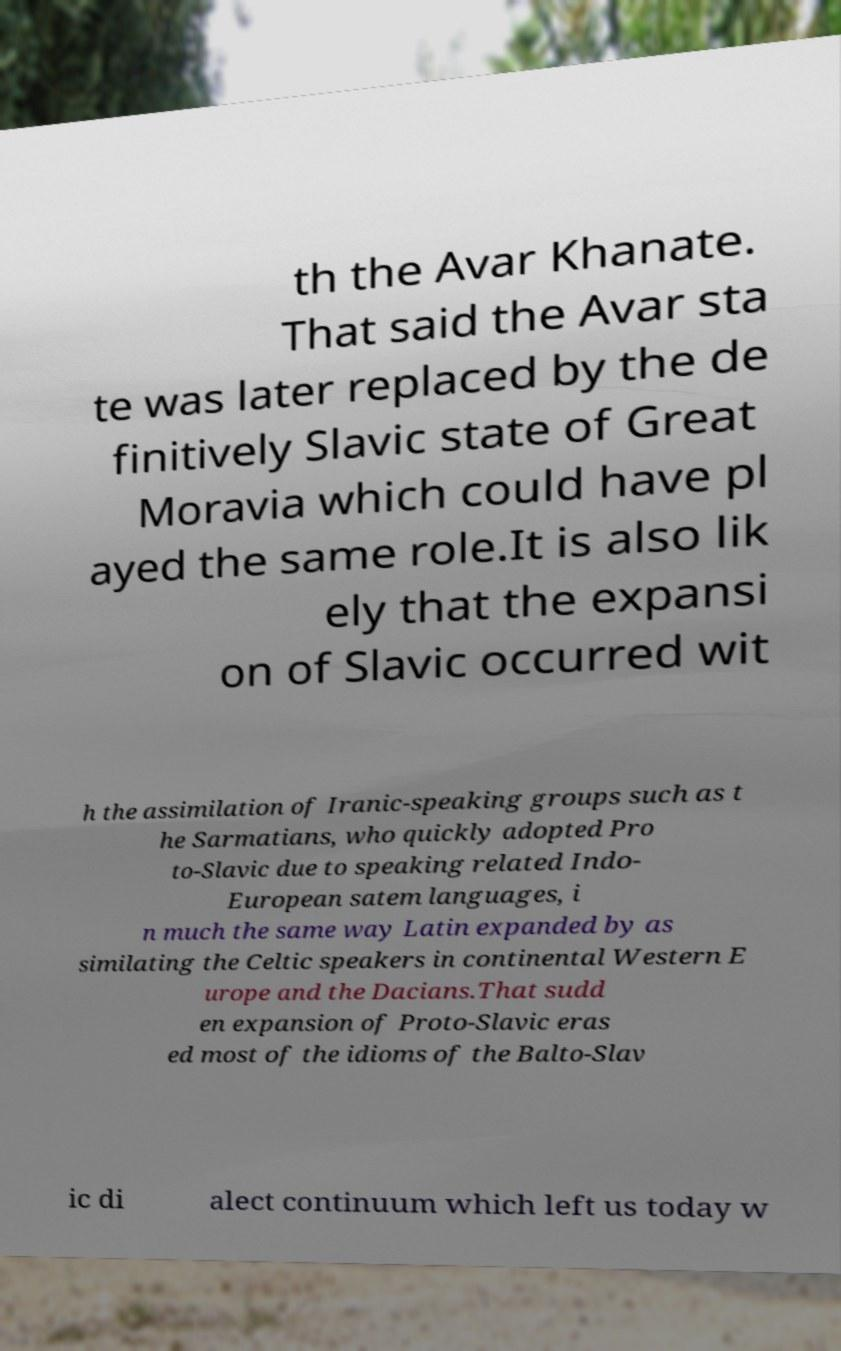There's text embedded in this image that I need extracted. Can you transcribe it verbatim? th the Avar Khanate. That said the Avar sta te was later replaced by the de finitively Slavic state of Great Moravia which could have pl ayed the same role.It is also lik ely that the expansi on of Slavic occurred wit h the assimilation of Iranic-speaking groups such as t he Sarmatians, who quickly adopted Pro to-Slavic due to speaking related Indo- European satem languages, i n much the same way Latin expanded by as similating the Celtic speakers in continental Western E urope and the Dacians.That sudd en expansion of Proto-Slavic eras ed most of the idioms of the Balto-Slav ic di alect continuum which left us today w 